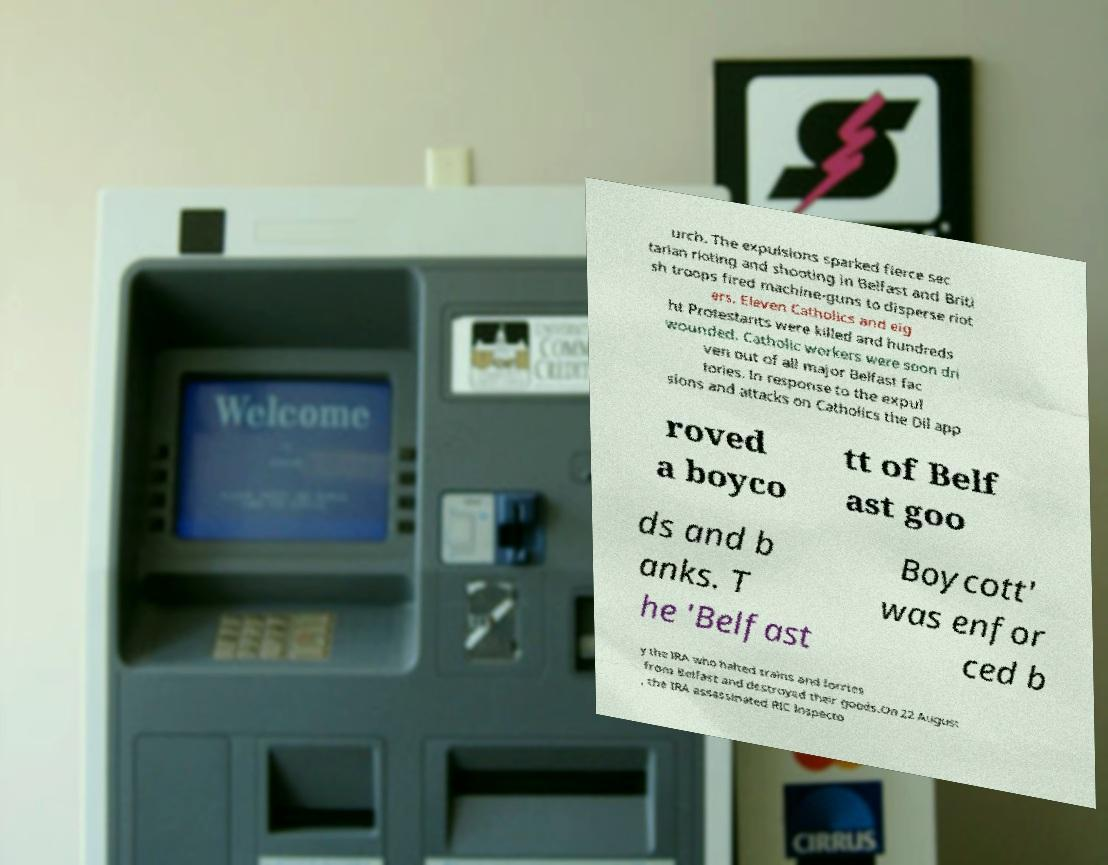What messages or text are displayed in this image? I need them in a readable, typed format. urch. The expulsions sparked fierce sec tarian rioting and shooting in Belfast and Briti sh troops fired machine-guns to disperse riot ers. Eleven Catholics and eig ht Protestants were killed and hundreds wounded. Catholic workers were soon dri ven out of all major Belfast fac tories. In response to the expul sions and attacks on Catholics the Dil app roved a boyco tt of Belf ast goo ds and b anks. T he 'Belfast Boycott' was enfor ced b y the IRA who halted trains and lorries from Belfast and destroyed their goods.On 22 August , the IRA assassinated RIC Inspecto 